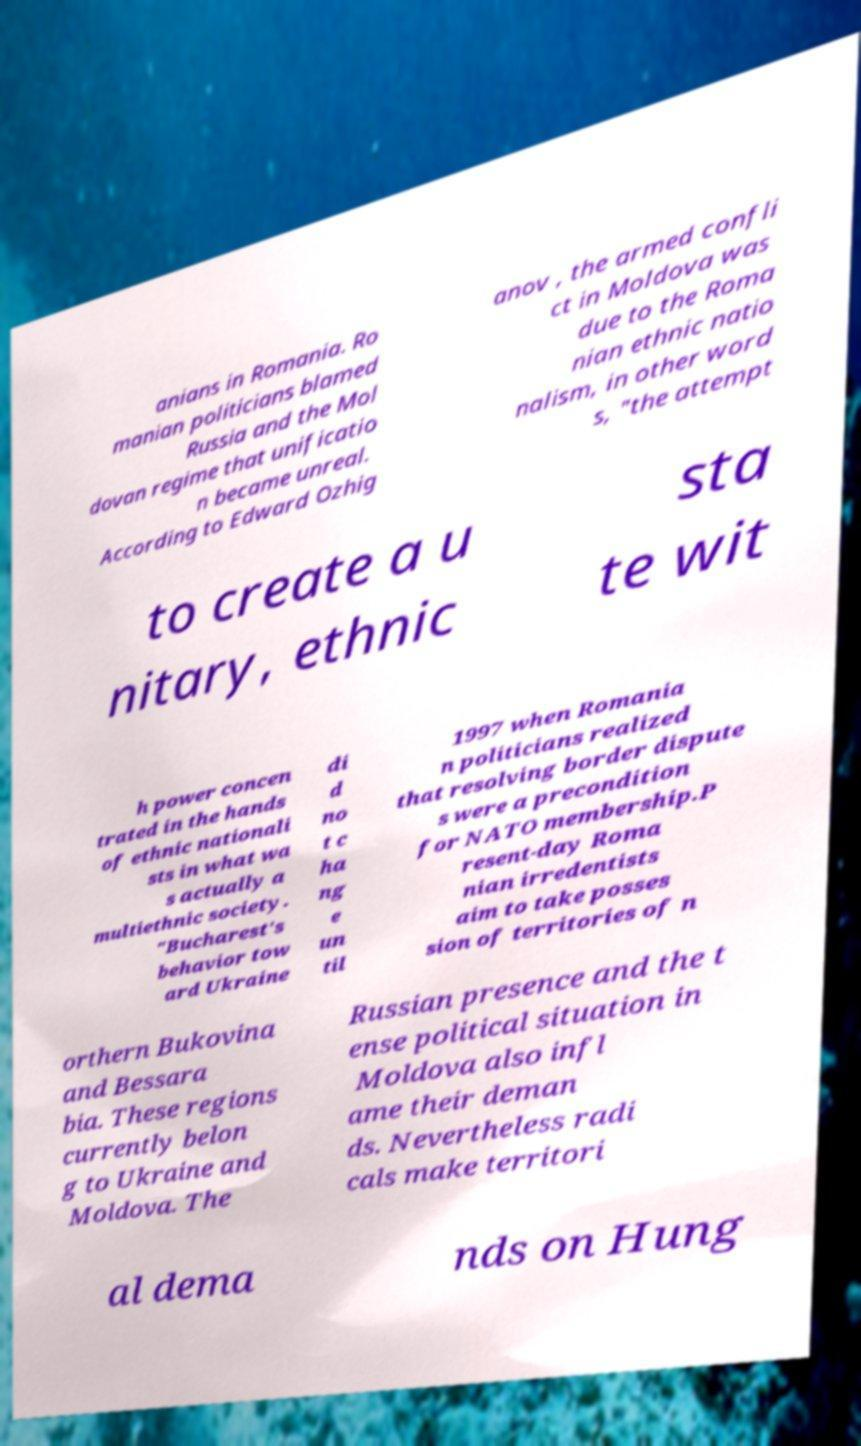Please read and relay the text visible in this image. What does it say? anians in Romania. Ro manian politicians blamed Russia and the Mol dovan regime that unificatio n became unreal. According to Edward Ozhig anov , the armed confli ct in Moldova was due to the Roma nian ethnic natio nalism, in other word s, "the attempt to create a u nitary, ethnic sta te wit h power concen trated in the hands of ethnic nationali sts in what wa s actually a multiethnic society. "Bucharest's behavior tow ard Ukraine di d no t c ha ng e un til 1997 when Romania n politicians realized that resolving border dispute s were a precondition for NATO membership.P resent-day Roma nian irredentists aim to take posses sion of territories of n orthern Bukovina and Bessara bia. These regions currently belon g to Ukraine and Moldova. The Russian presence and the t ense political situation in Moldova also infl ame their deman ds. Nevertheless radi cals make territori al dema nds on Hung 